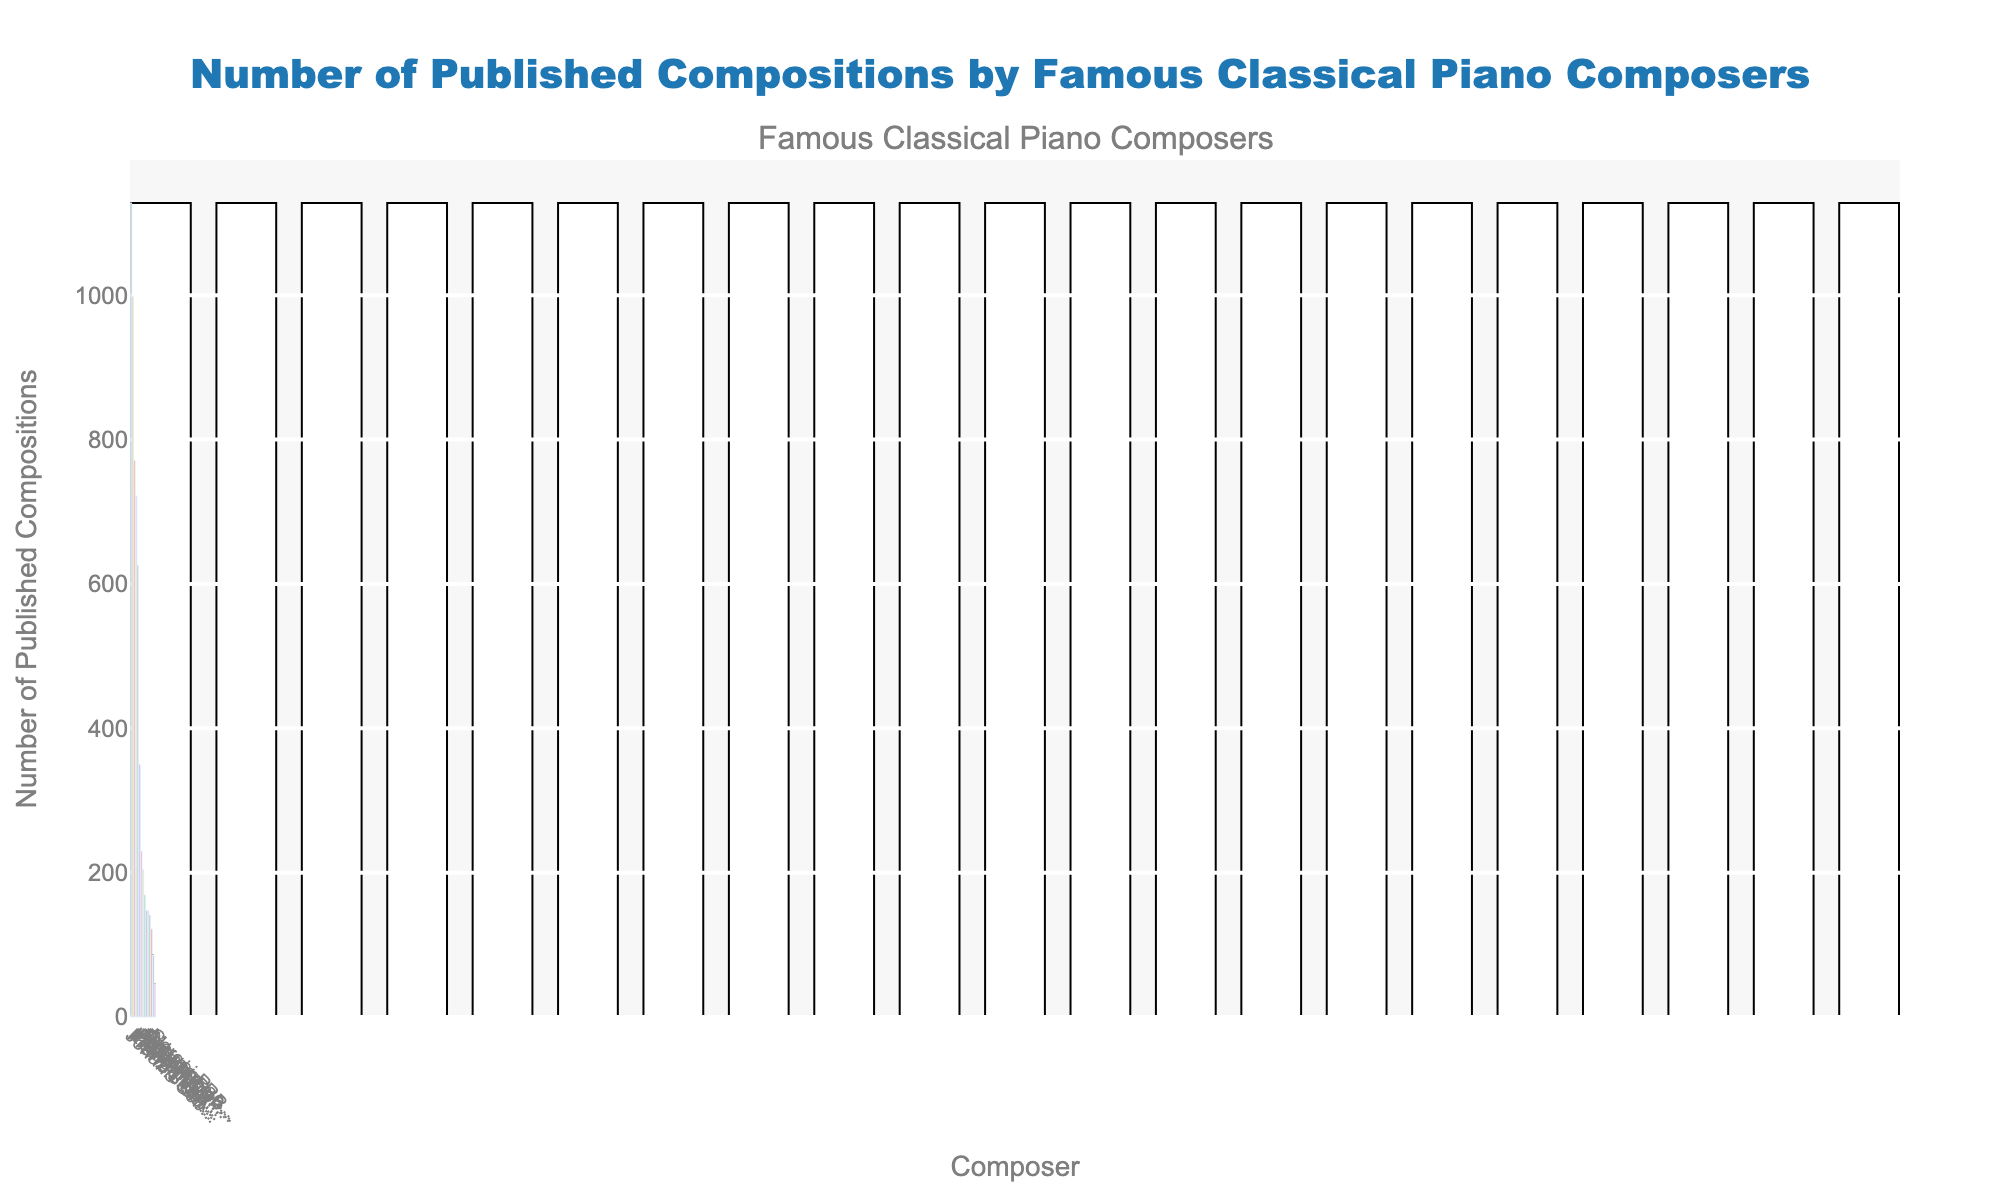What composer has the highest number of published compositions? By observing the heights of the bars and the numerical labels, Johann Sebastian Bach has the highest with 1128 published compositions.
Answer: Johann Sebastian Bach Which two composers have the closest number of published compositions, and what is the difference between them? By comparing the heights and values of the bars, Felix Mendelssohn (350) and Antonín Dvořák (204) seem relatively close. The difference is 350 - 204 = 146.
Answer: Felix Mendelssohn and Antonín Dvořák, 146 Who published more compositions, Ludwig van Beethoven or Franz Liszt? By comparing their respective bars, Franz Liszt published 771 compositions whereas Ludwig van Beethoven published 722 compositions. Therefore, Franz Liszt published more.
Answer: Franz Liszt How many total compositions did Wolfgang Amadeus Mozart, Franz Schubert, and Johannes Brahms publish? By adding the numbers from the bars for these composers: 626 (Mozart) + 998 (Schubert) + 122 (Brahms) = 1746 compositions.
Answer: 1746 Who has the median number of published compositions when the composers are sorted in descending order? To find the median, list the composers in descending order of their compositions and locate the middle value. This would be Frédéric Chopin, who has 230 compositions.
Answer: Frédéric Chopin Which composer has the least number of published compositions and what is that number? By observing the smallest bar, Sergei Rachmaninoff has the least number of published compositions with 45.
Answer: Sergei Rachmaninoff, 45 What is the average number of published compositions for these composers? Sum all the number of compositions and divide by the number of composers: (1128 + 626 + 722 + 230 + 998 + 122 + 771 + 141 + 45 + 148 + 169 + 85 + 350 + 147 + 204) / 15 = 4327 / 15 ≈ 286
Answer: 286 Which composers have published fewer than 150 compositions? By observing the bars and their values, the composers are Claude Debussy (141), Dmitri Shostakovich (147), Sergei Rachmaninoff (45), and Maurice Ravel (85).
Answer: Claude Debussy, Dmitri Shostakovich, Sergei Rachmaninoff, Maurice Ravel What is the combined total of compositions published by Johann Sebastian Bach, Wolfang Amadeus Mozart, and Ludwig van Beethoven? Sum the compositions for these composers: 1128 (Bach) + 626 (Mozart) + 722 (Beethoven) = 2476.
Answer: 2476 Who published more, Robert Schumann or Pyotr Ilyich Tchaikovsky, and by how much? By comparing their bars, Robert Schumann has 148 compositions and Pyotr Ilyich Tchaikovsky has 169. Therefore, Tchaikovsky published more by 169 - 148 = 21.
Answer: Pyotr Ilyich Tchaikovsky, 21 